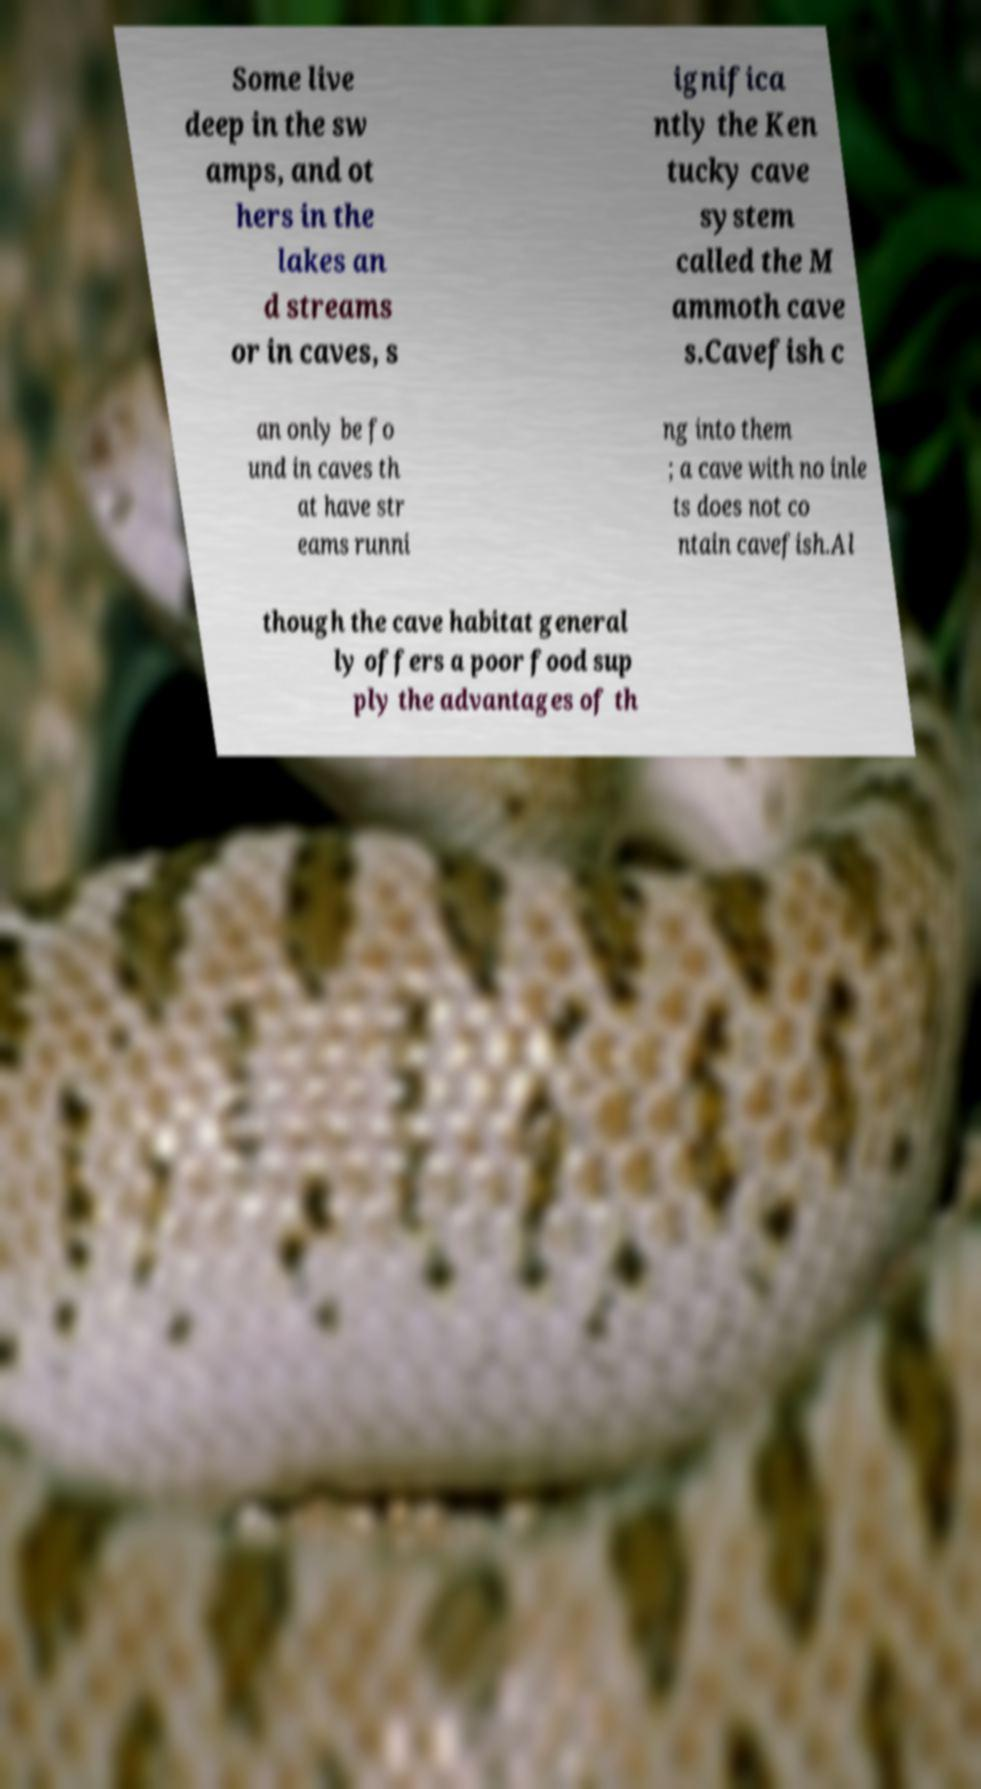Could you assist in decoding the text presented in this image and type it out clearly? Some live deep in the sw amps, and ot hers in the lakes an d streams or in caves, s ignifica ntly the Ken tucky cave system called the M ammoth cave s.Cavefish c an only be fo und in caves th at have str eams runni ng into them ; a cave with no inle ts does not co ntain cavefish.Al though the cave habitat general ly offers a poor food sup ply the advantages of th 